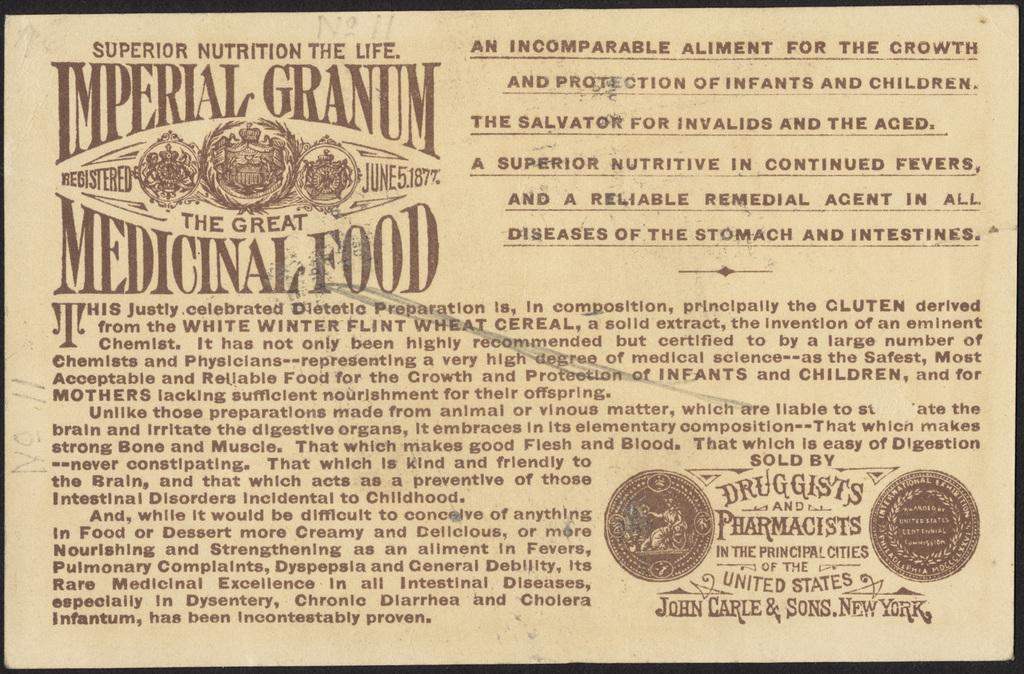<image>
Relay a brief, clear account of the picture shown. An antique article explaining the benefits of Imperial Granum. 